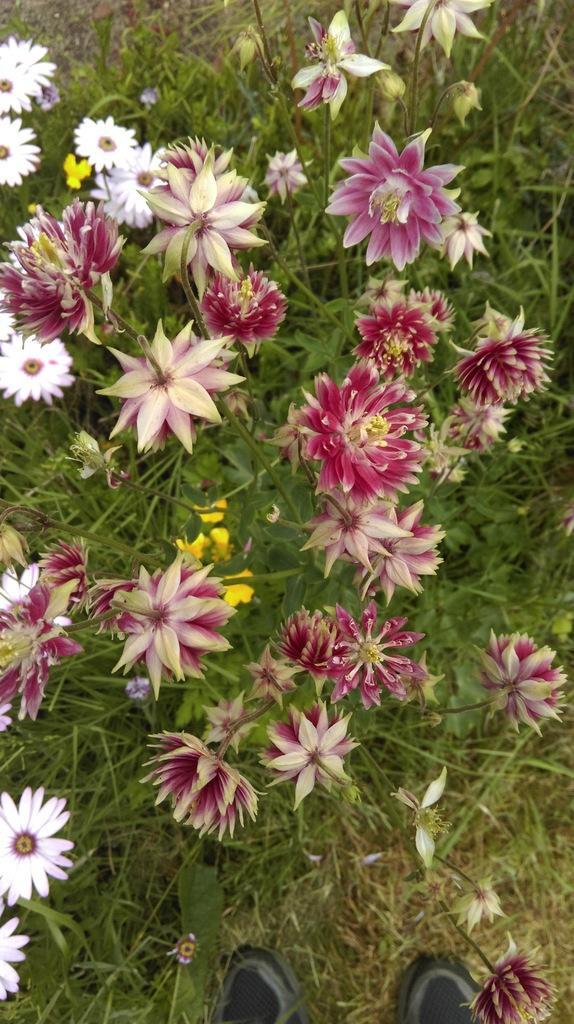In one or two sentences, can you explain what this image depicts? In this image I can see plants on which I can see flowers , at the bottom there are shoes visible on grass. 